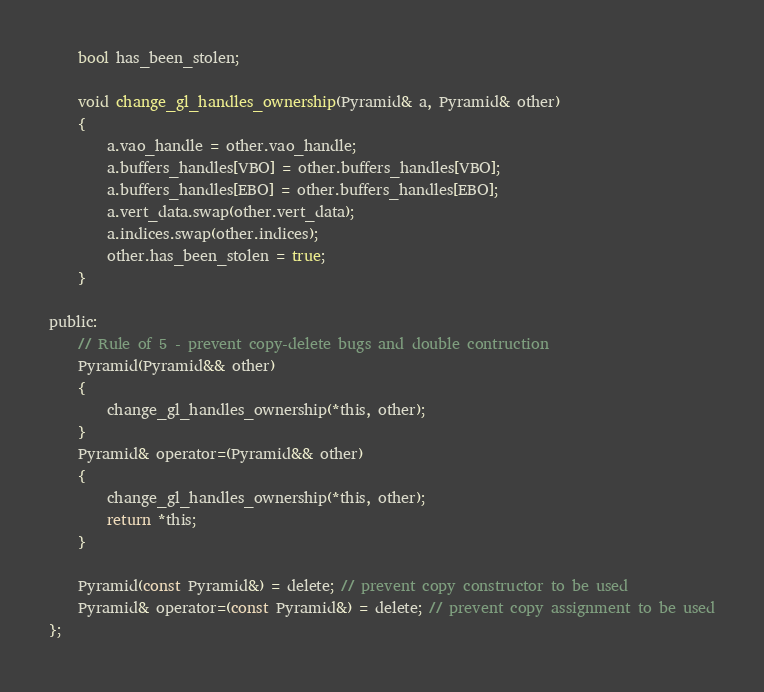Convert code to text. <code><loc_0><loc_0><loc_500><loc_500><_C_>
	bool has_been_stolen;

	void change_gl_handles_ownership(Pyramid& a, Pyramid& other)
	{
		a.vao_handle = other.vao_handle;
		a.buffers_handles[VBO] = other.buffers_handles[VBO];
		a.buffers_handles[EBO] = other.buffers_handles[EBO];
		a.vert_data.swap(other.vert_data);
		a.indices.swap(other.indices);
		other.has_been_stolen = true;
	}

public:
	// Rule of 5 - prevent copy-delete bugs and double contruction
	Pyramid(Pyramid&& other)
	{
		change_gl_handles_ownership(*this, other);
	}
	Pyramid& operator=(Pyramid&& other)
	{
		change_gl_handles_ownership(*this, other);
		return *this;
	}

	Pyramid(const Pyramid&) = delete; // prevent copy constructor to be used
	Pyramid& operator=(const Pyramid&) = delete; // prevent copy assignment to be used
};</code> 